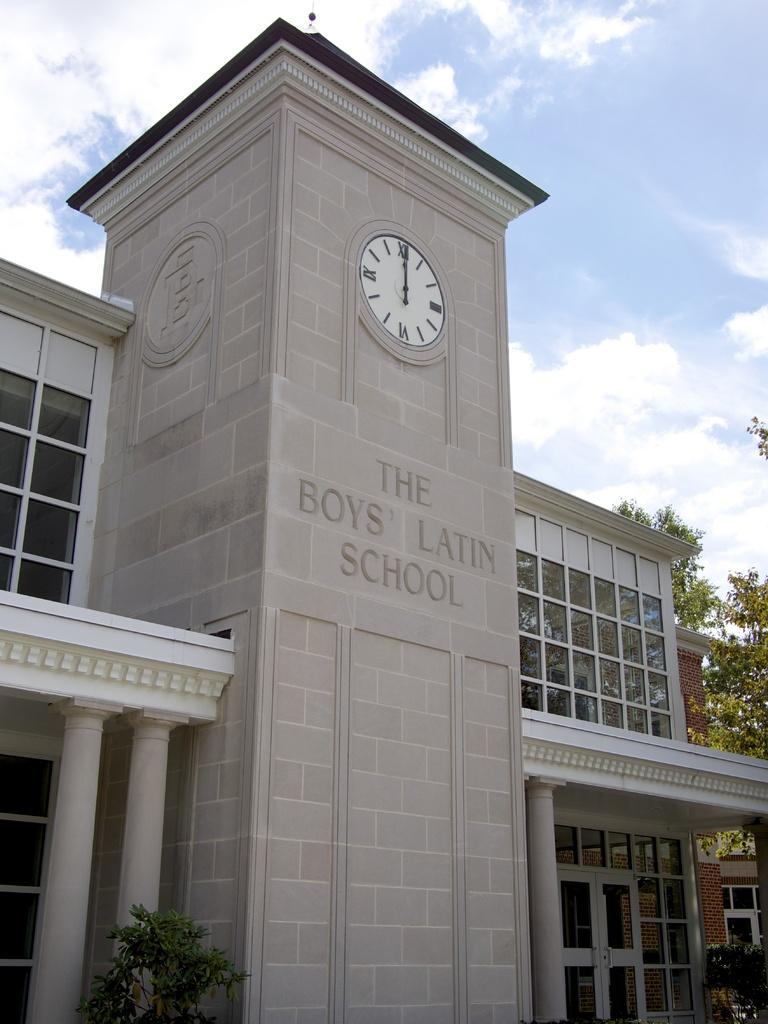<image>
Offer a succinct explanation of the picture presented. The front of a school called The Boys' Latin School. 